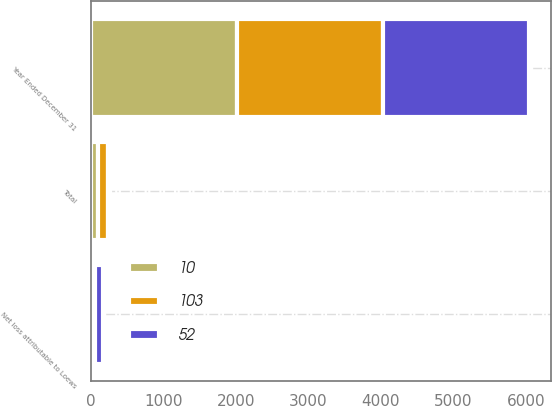Convert chart. <chart><loc_0><loc_0><loc_500><loc_500><stacked_bar_chart><ecel><fcel>Year Ended December 31<fcel>Total<fcel>Net loss attributable to Loews<nl><fcel>52<fcel>2015<fcel>28<fcel>103<nl><fcel>10<fcel>2014<fcel>97<fcel>52<nl><fcel>103<fcel>2013<fcel>143<fcel>10<nl></chart> 